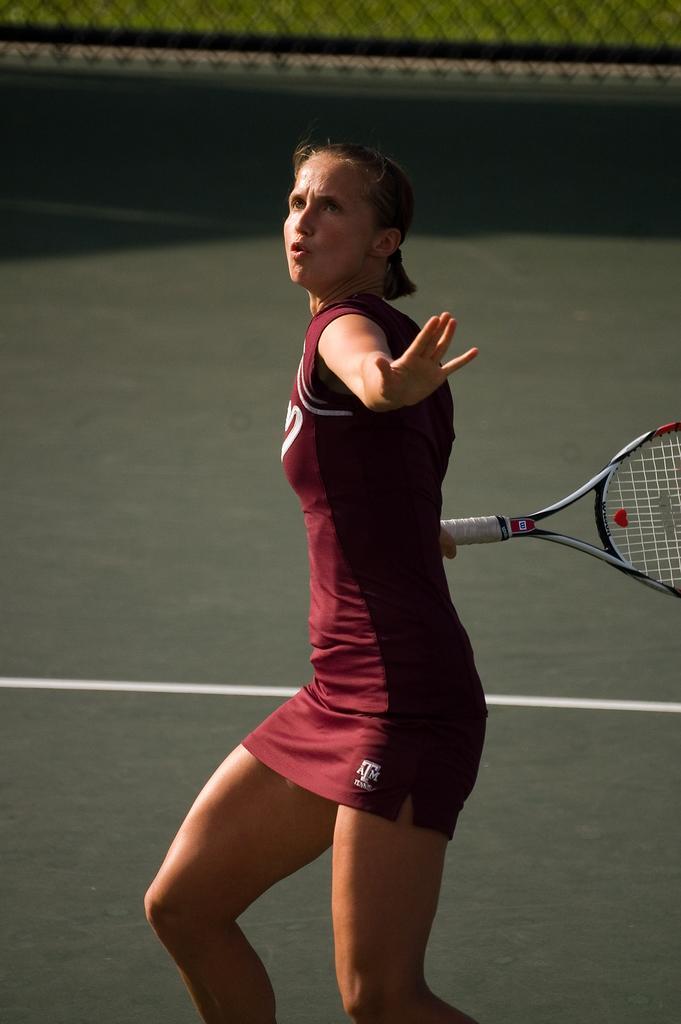In one or two sentences, can you explain what this image depicts? In this picture there is a woman holding a racket in her hand and is about to hit the ball. She wore a red jersey. In the background there is mesh and grass. 